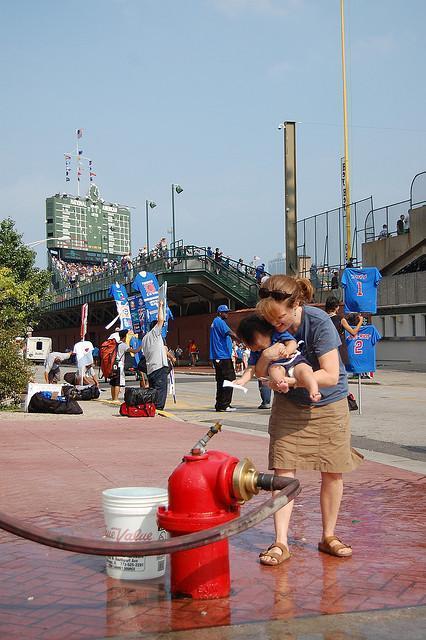How many people are in the photo?
Give a very brief answer. 4. 